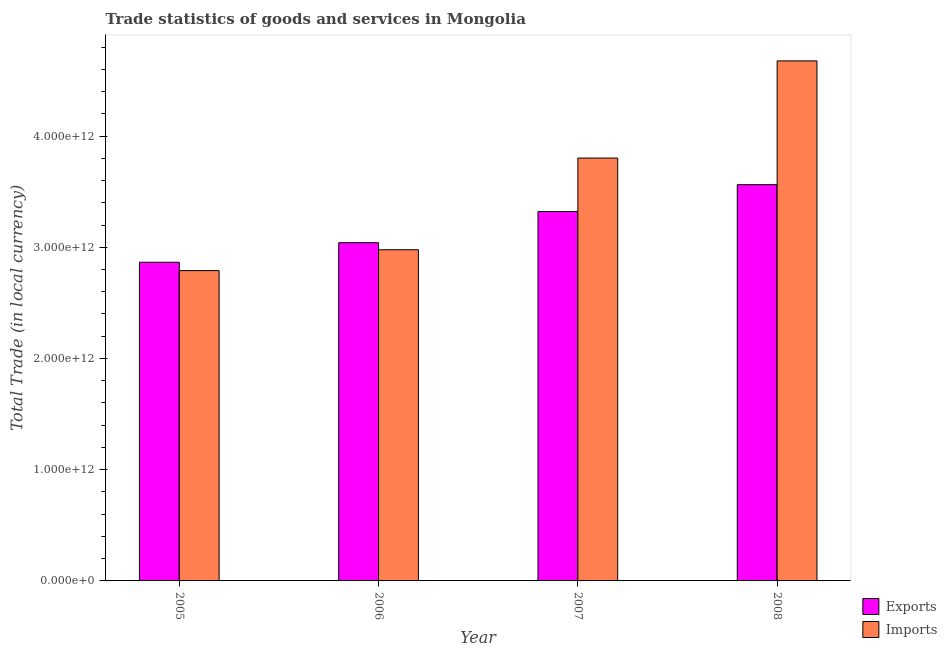How many different coloured bars are there?
Offer a terse response. 2. Are the number of bars per tick equal to the number of legend labels?
Keep it short and to the point. Yes. Are the number of bars on each tick of the X-axis equal?
Offer a very short reply. Yes. What is the label of the 1st group of bars from the left?
Your answer should be very brief. 2005. What is the export of goods and services in 2008?
Offer a very short reply. 3.56e+12. Across all years, what is the maximum imports of goods and services?
Keep it short and to the point. 4.68e+12. Across all years, what is the minimum export of goods and services?
Provide a short and direct response. 2.87e+12. What is the total imports of goods and services in the graph?
Offer a very short reply. 1.42e+13. What is the difference between the imports of goods and services in 2006 and that in 2007?
Your response must be concise. -8.24e+11. What is the difference between the export of goods and services in 2006 and the imports of goods and services in 2007?
Your answer should be very brief. -2.80e+11. What is the average export of goods and services per year?
Keep it short and to the point. 3.20e+12. What is the ratio of the export of goods and services in 2007 to that in 2008?
Offer a terse response. 0.93. Is the export of goods and services in 2007 less than that in 2008?
Your answer should be very brief. Yes. Is the difference between the imports of goods and services in 2006 and 2007 greater than the difference between the export of goods and services in 2006 and 2007?
Offer a terse response. No. What is the difference between the highest and the second highest imports of goods and services?
Make the answer very short. 8.74e+11. What is the difference between the highest and the lowest export of goods and services?
Your answer should be very brief. 6.98e+11. In how many years, is the imports of goods and services greater than the average imports of goods and services taken over all years?
Provide a succinct answer. 2. Is the sum of the export of goods and services in 2006 and 2008 greater than the maximum imports of goods and services across all years?
Ensure brevity in your answer.  Yes. What does the 2nd bar from the left in 2008 represents?
Your answer should be very brief. Imports. What does the 2nd bar from the right in 2005 represents?
Your answer should be compact. Exports. Are all the bars in the graph horizontal?
Keep it short and to the point. No. How many years are there in the graph?
Offer a terse response. 4. What is the difference between two consecutive major ticks on the Y-axis?
Ensure brevity in your answer.  1.00e+12. Are the values on the major ticks of Y-axis written in scientific E-notation?
Your response must be concise. Yes. Does the graph contain any zero values?
Make the answer very short. No. What is the title of the graph?
Provide a succinct answer. Trade statistics of goods and services in Mongolia. Does "Net savings(excluding particulate emission damage)" appear as one of the legend labels in the graph?
Your answer should be very brief. No. What is the label or title of the X-axis?
Ensure brevity in your answer.  Year. What is the label or title of the Y-axis?
Keep it short and to the point. Total Trade (in local currency). What is the Total Trade (in local currency) of Exports in 2005?
Offer a very short reply. 2.87e+12. What is the Total Trade (in local currency) of Imports in 2005?
Keep it short and to the point. 2.79e+12. What is the Total Trade (in local currency) in Exports in 2006?
Provide a short and direct response. 3.04e+12. What is the Total Trade (in local currency) in Imports in 2006?
Provide a succinct answer. 2.98e+12. What is the Total Trade (in local currency) in Exports in 2007?
Give a very brief answer. 3.32e+12. What is the Total Trade (in local currency) in Imports in 2007?
Keep it short and to the point. 3.80e+12. What is the Total Trade (in local currency) of Exports in 2008?
Offer a very short reply. 3.56e+12. What is the Total Trade (in local currency) of Imports in 2008?
Your answer should be compact. 4.68e+12. Across all years, what is the maximum Total Trade (in local currency) of Exports?
Keep it short and to the point. 3.56e+12. Across all years, what is the maximum Total Trade (in local currency) in Imports?
Give a very brief answer. 4.68e+12. Across all years, what is the minimum Total Trade (in local currency) of Exports?
Your response must be concise. 2.87e+12. Across all years, what is the minimum Total Trade (in local currency) in Imports?
Provide a short and direct response. 2.79e+12. What is the total Total Trade (in local currency) of Exports in the graph?
Offer a terse response. 1.28e+13. What is the total Total Trade (in local currency) in Imports in the graph?
Your response must be concise. 1.42e+13. What is the difference between the Total Trade (in local currency) of Exports in 2005 and that in 2006?
Provide a short and direct response. -1.76e+11. What is the difference between the Total Trade (in local currency) in Imports in 2005 and that in 2006?
Your answer should be very brief. -1.88e+11. What is the difference between the Total Trade (in local currency) in Exports in 2005 and that in 2007?
Provide a succinct answer. -4.56e+11. What is the difference between the Total Trade (in local currency) of Imports in 2005 and that in 2007?
Your answer should be very brief. -1.01e+12. What is the difference between the Total Trade (in local currency) in Exports in 2005 and that in 2008?
Your answer should be compact. -6.98e+11. What is the difference between the Total Trade (in local currency) of Imports in 2005 and that in 2008?
Provide a succinct answer. -1.89e+12. What is the difference between the Total Trade (in local currency) in Exports in 2006 and that in 2007?
Ensure brevity in your answer.  -2.80e+11. What is the difference between the Total Trade (in local currency) in Imports in 2006 and that in 2007?
Provide a short and direct response. -8.24e+11. What is the difference between the Total Trade (in local currency) in Exports in 2006 and that in 2008?
Offer a terse response. -5.22e+11. What is the difference between the Total Trade (in local currency) of Imports in 2006 and that in 2008?
Offer a terse response. -1.70e+12. What is the difference between the Total Trade (in local currency) in Exports in 2007 and that in 2008?
Provide a short and direct response. -2.42e+11. What is the difference between the Total Trade (in local currency) of Imports in 2007 and that in 2008?
Provide a succinct answer. -8.74e+11. What is the difference between the Total Trade (in local currency) of Exports in 2005 and the Total Trade (in local currency) of Imports in 2006?
Give a very brief answer. -1.12e+11. What is the difference between the Total Trade (in local currency) in Exports in 2005 and the Total Trade (in local currency) in Imports in 2007?
Offer a terse response. -9.37e+11. What is the difference between the Total Trade (in local currency) in Exports in 2005 and the Total Trade (in local currency) in Imports in 2008?
Make the answer very short. -1.81e+12. What is the difference between the Total Trade (in local currency) of Exports in 2006 and the Total Trade (in local currency) of Imports in 2007?
Ensure brevity in your answer.  -7.61e+11. What is the difference between the Total Trade (in local currency) of Exports in 2006 and the Total Trade (in local currency) of Imports in 2008?
Your answer should be compact. -1.63e+12. What is the difference between the Total Trade (in local currency) in Exports in 2007 and the Total Trade (in local currency) in Imports in 2008?
Make the answer very short. -1.35e+12. What is the average Total Trade (in local currency) of Exports per year?
Offer a very short reply. 3.20e+12. What is the average Total Trade (in local currency) in Imports per year?
Offer a very short reply. 3.56e+12. In the year 2005, what is the difference between the Total Trade (in local currency) in Exports and Total Trade (in local currency) in Imports?
Your response must be concise. 7.53e+1. In the year 2006, what is the difference between the Total Trade (in local currency) of Exports and Total Trade (in local currency) of Imports?
Make the answer very short. 6.35e+1. In the year 2007, what is the difference between the Total Trade (in local currency) of Exports and Total Trade (in local currency) of Imports?
Your response must be concise. -4.81e+11. In the year 2008, what is the difference between the Total Trade (in local currency) of Exports and Total Trade (in local currency) of Imports?
Your answer should be compact. -1.11e+12. What is the ratio of the Total Trade (in local currency) of Exports in 2005 to that in 2006?
Give a very brief answer. 0.94. What is the ratio of the Total Trade (in local currency) in Imports in 2005 to that in 2006?
Keep it short and to the point. 0.94. What is the ratio of the Total Trade (in local currency) in Exports in 2005 to that in 2007?
Give a very brief answer. 0.86. What is the ratio of the Total Trade (in local currency) of Imports in 2005 to that in 2007?
Your answer should be compact. 0.73. What is the ratio of the Total Trade (in local currency) in Exports in 2005 to that in 2008?
Keep it short and to the point. 0.8. What is the ratio of the Total Trade (in local currency) in Imports in 2005 to that in 2008?
Your response must be concise. 0.6. What is the ratio of the Total Trade (in local currency) in Exports in 2006 to that in 2007?
Provide a succinct answer. 0.92. What is the ratio of the Total Trade (in local currency) of Imports in 2006 to that in 2007?
Offer a very short reply. 0.78. What is the ratio of the Total Trade (in local currency) of Exports in 2006 to that in 2008?
Offer a very short reply. 0.85. What is the ratio of the Total Trade (in local currency) in Imports in 2006 to that in 2008?
Make the answer very short. 0.64. What is the ratio of the Total Trade (in local currency) in Exports in 2007 to that in 2008?
Ensure brevity in your answer.  0.93. What is the ratio of the Total Trade (in local currency) in Imports in 2007 to that in 2008?
Provide a short and direct response. 0.81. What is the difference between the highest and the second highest Total Trade (in local currency) in Exports?
Your response must be concise. 2.42e+11. What is the difference between the highest and the second highest Total Trade (in local currency) in Imports?
Make the answer very short. 8.74e+11. What is the difference between the highest and the lowest Total Trade (in local currency) of Exports?
Your answer should be very brief. 6.98e+11. What is the difference between the highest and the lowest Total Trade (in local currency) in Imports?
Keep it short and to the point. 1.89e+12. 